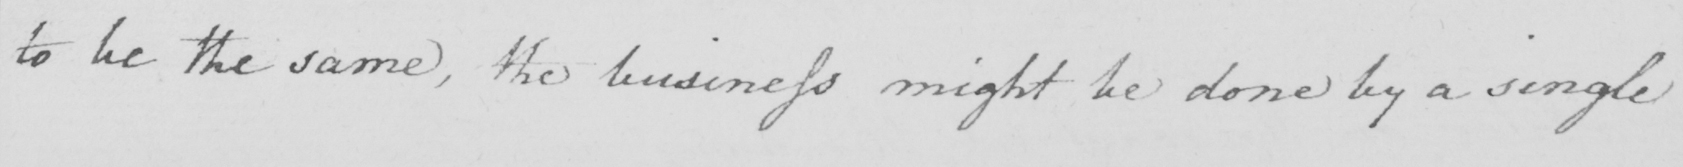Please transcribe the handwritten text in this image. to be the same , the business might be done by a single 